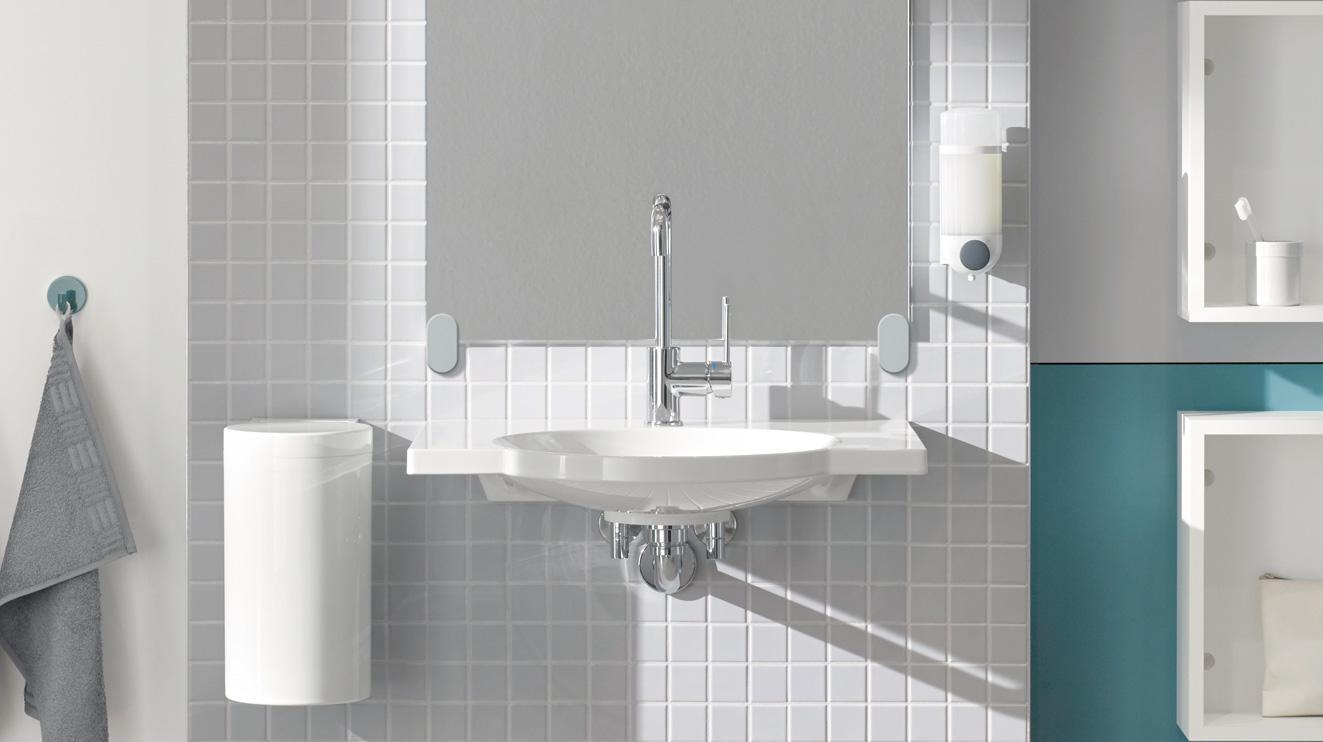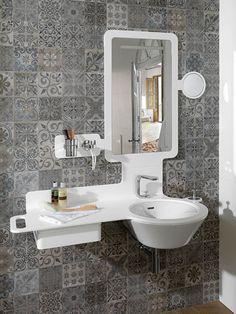The first image is the image on the left, the second image is the image on the right. For the images displayed, is the sentence "A jar of fernlike foliage and a leaning framed picture are next to a rectangular gray sink mounted on a wood plank." factually correct? Answer yes or no. No. The first image is the image on the left, the second image is the image on the right. Considering the images on both sides, is "The sink in one of the images is set into a brown wood hanging counter." valid? Answer yes or no. No. 